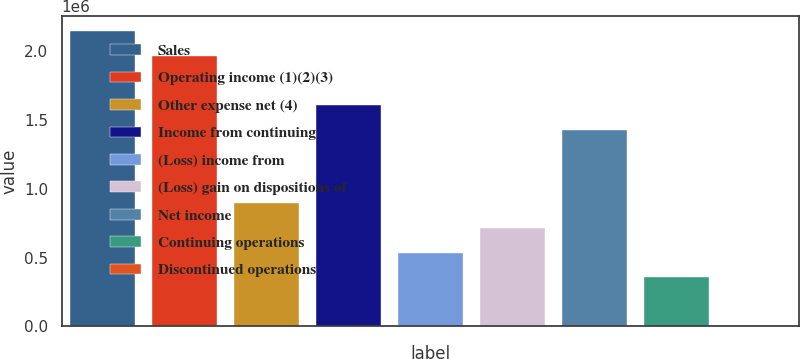<chart> <loc_0><loc_0><loc_500><loc_500><bar_chart><fcel>Sales<fcel>Operating income (1)(2)(3)<fcel>Other expense net (4)<fcel>Income from continuing<fcel>(Loss) income from<fcel>(Loss) gain on dispositions of<fcel>Net income<fcel>Continuing operations<fcel>Discontinued operations<nl><fcel>2.1448e+06<fcel>1.96606e+06<fcel>893666<fcel>1.6086e+06<fcel>536199<fcel>714932<fcel>1.42986e+06<fcel>357466<fcel>0.02<nl></chart> 